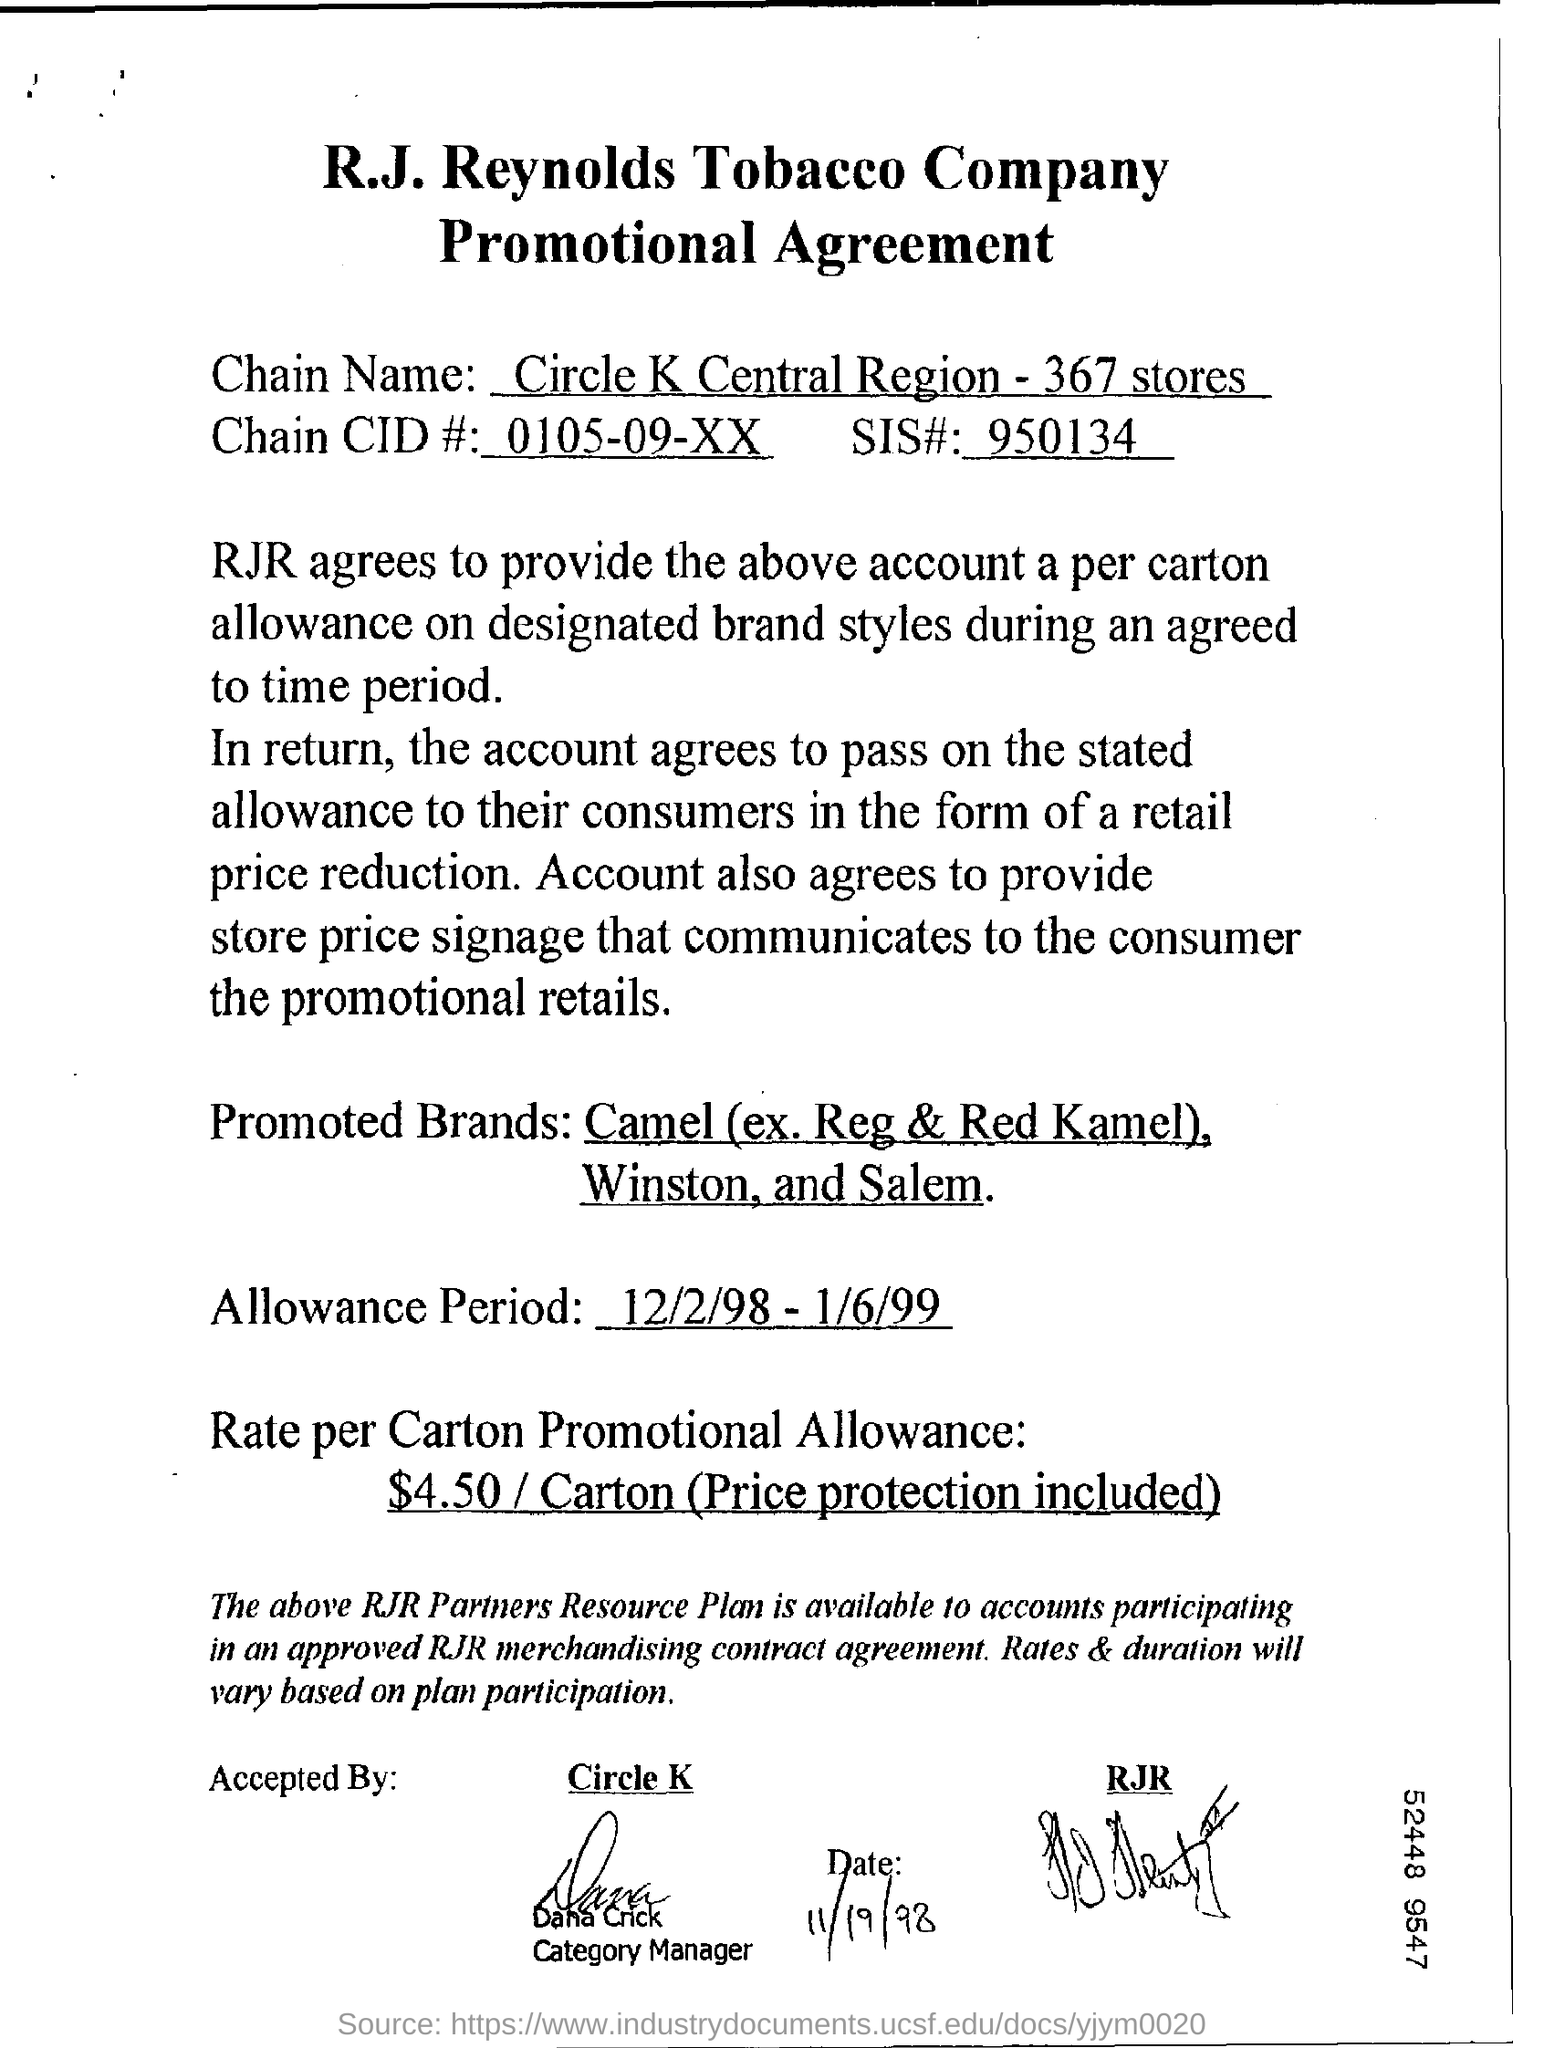Can you tell me what brands are being promoted in this agreement? The promotional agreement lists Camel (excluding Regular and Red Kamel), Winston, and Salem as the brands being promoted.  What is the duration of this promotional agreement? The promotional agreement is valid from December 2, 1998, through January 6, 1999. 